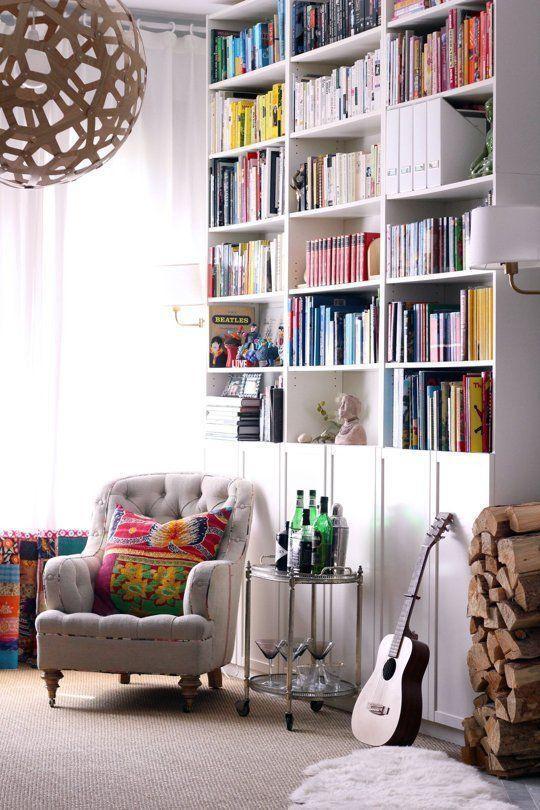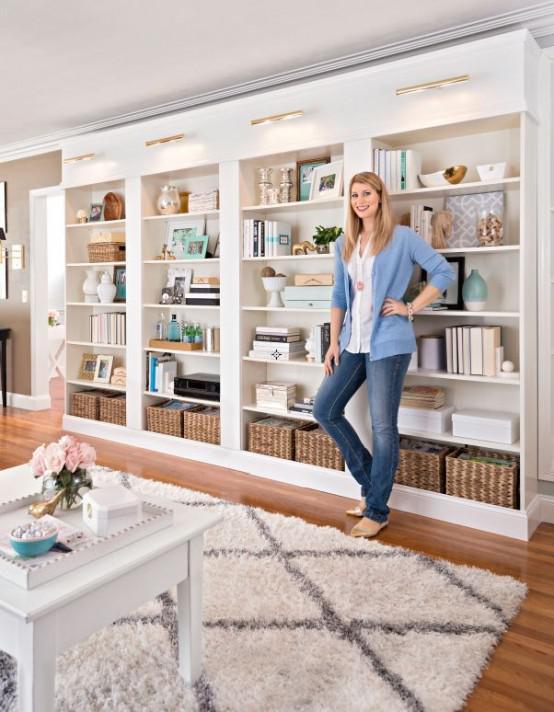The first image is the image on the left, the second image is the image on the right. Considering the images on both sides, is "a bookshelf is behind a small white table" valid? Answer yes or no. Yes. The first image is the image on the left, the second image is the image on the right. Analyze the images presented: Is the assertion "The bookshelves in both pictures are facing the left side of the picture." valid? Answer yes or no. Yes. 